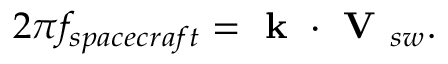<formula> <loc_0><loc_0><loc_500><loc_500>2 \pi f _ { s p a c e c r a f t } = k \cdot V _ { s w } .</formula> 